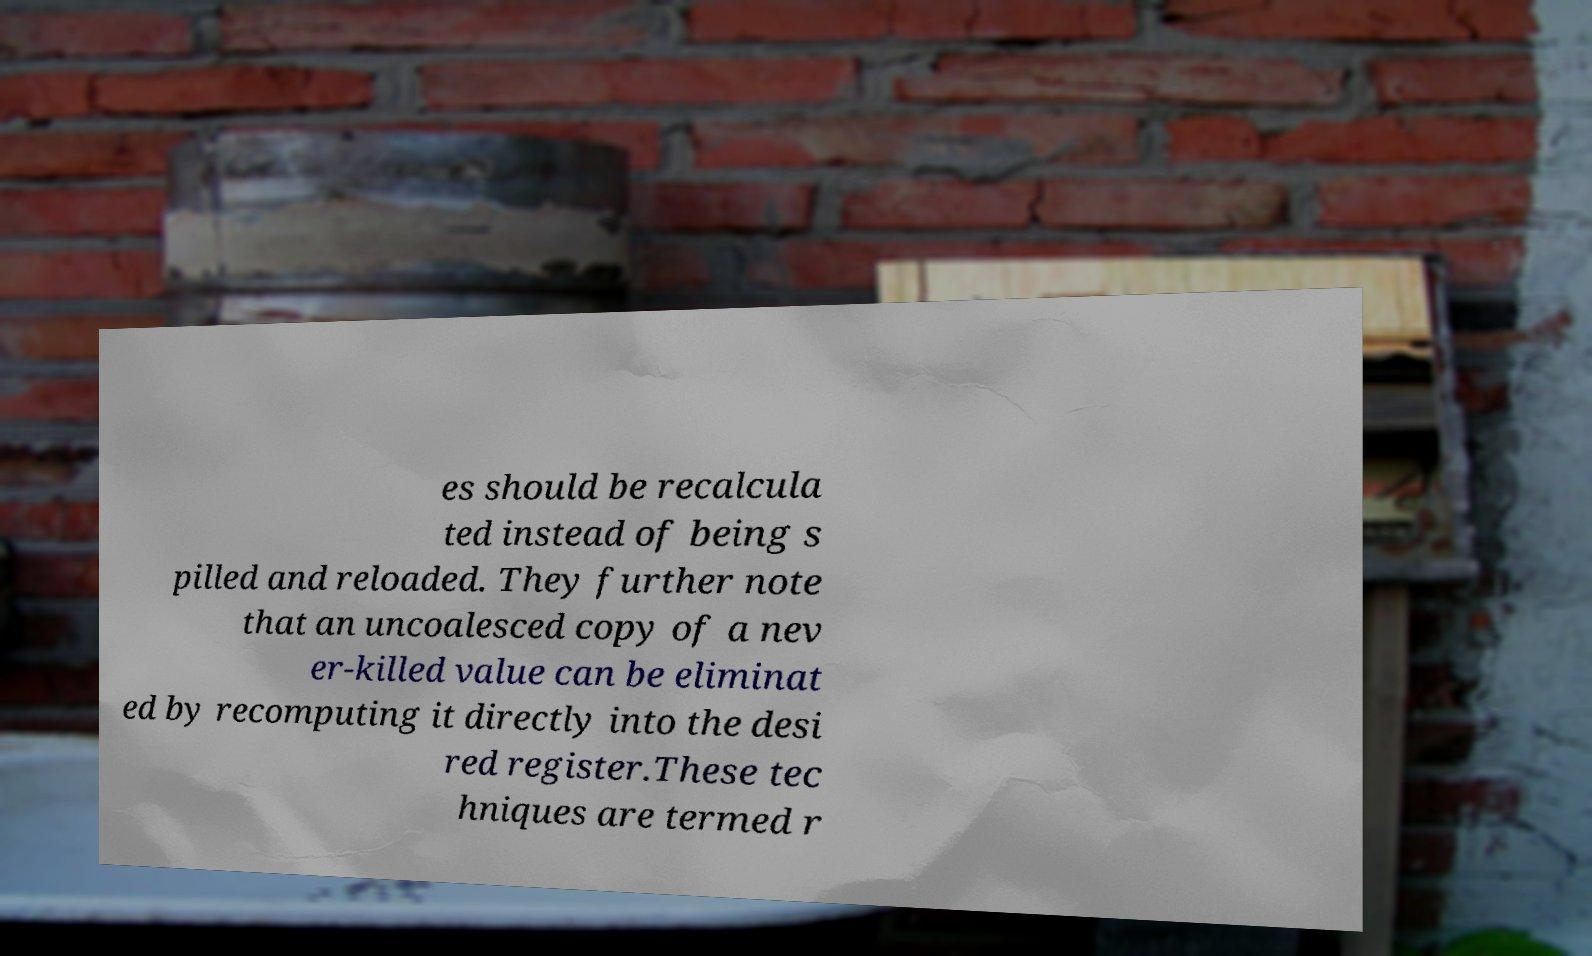Can you accurately transcribe the text from the provided image for me? es should be recalcula ted instead of being s pilled and reloaded. They further note that an uncoalesced copy of a nev er-killed value can be eliminat ed by recomputing it directly into the desi red register.These tec hniques are termed r 